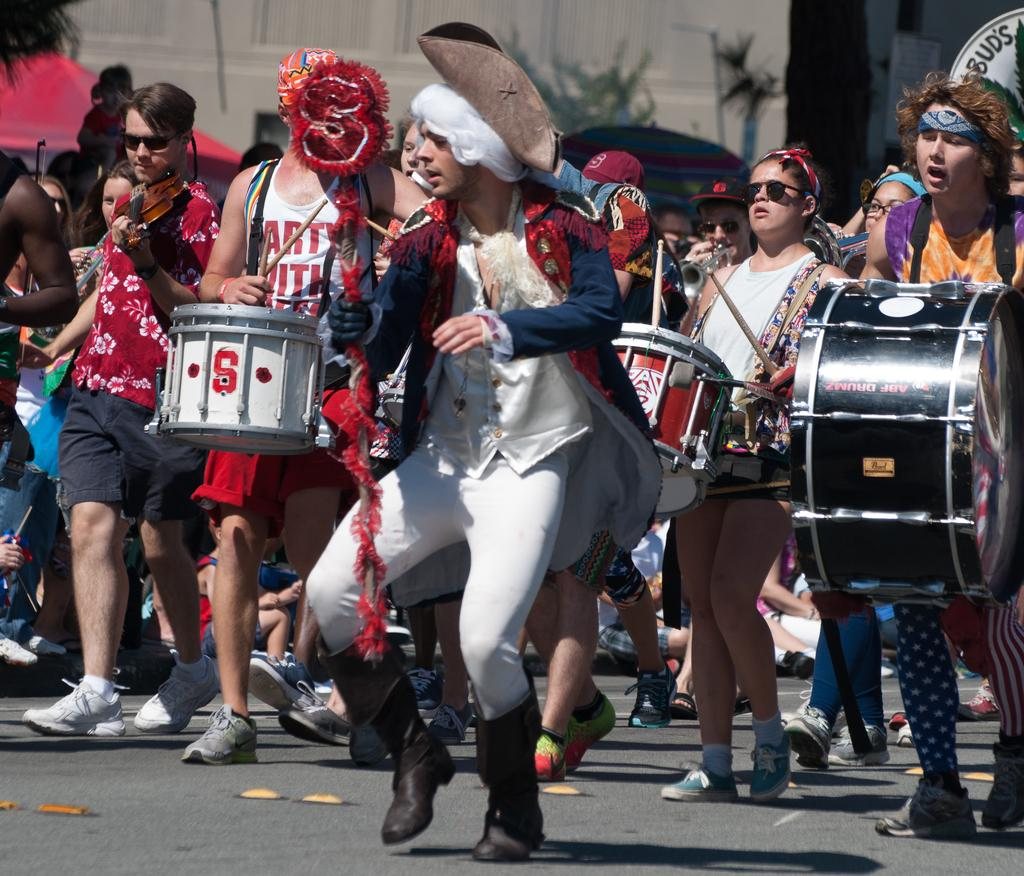What are the persons in the image doing? The persons in the image are playing musical instruments. What type of setting is the scene taking place in? The location of the scene is on the road. What is the thing that burns on the road in the image? There is no thing that burns on the road in the image; the scene shows persons playing musical instruments. 